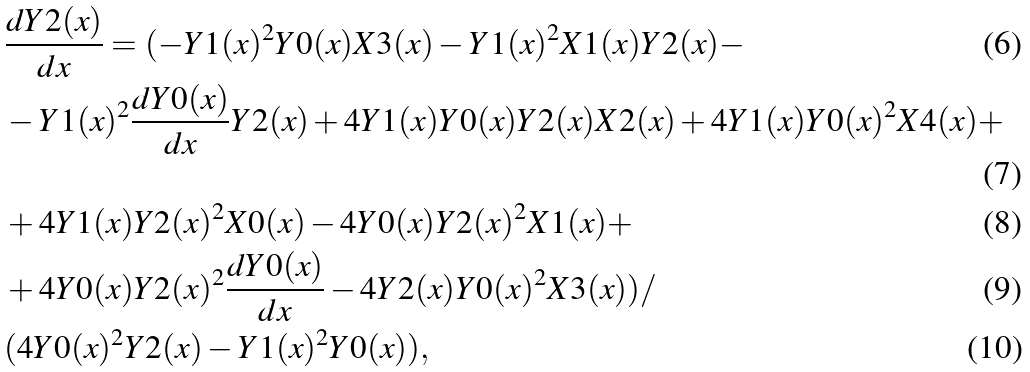Convert formula to latex. <formula><loc_0><loc_0><loc_500><loc_500>& \frac { d Y 2 ( x ) } { d x } = ( - Y 1 ( x ) ^ { 2 } Y 0 ( x ) X 3 ( x ) - Y 1 ( x ) ^ { 2 } X 1 ( x ) Y 2 ( x ) - \\ & - Y 1 ( x ) ^ { 2 } \frac { d Y 0 ( x ) } { d x } Y 2 ( x ) + 4 Y 1 ( x ) Y 0 ( x ) Y 2 ( x ) X 2 ( x ) + 4 Y 1 ( x ) Y 0 ( x ) ^ { 2 } X 4 ( x ) + \\ & + 4 Y 1 ( x ) Y 2 ( x ) ^ { 2 } X 0 ( x ) - 4 Y 0 ( x ) Y 2 ( x ) ^ { 2 } X 1 ( x ) + \\ & + 4 Y 0 ( x ) Y 2 ( x ) ^ { 2 } \frac { d Y 0 ( x ) } { d x } - 4 Y 2 ( x ) Y 0 ( x ) ^ { 2 } X 3 ( x ) ) / \\ & ( 4 Y 0 ( x ) ^ { 2 } Y 2 ( x ) - Y 1 ( x ) ^ { 2 } Y 0 ( x ) ) ,</formula> 